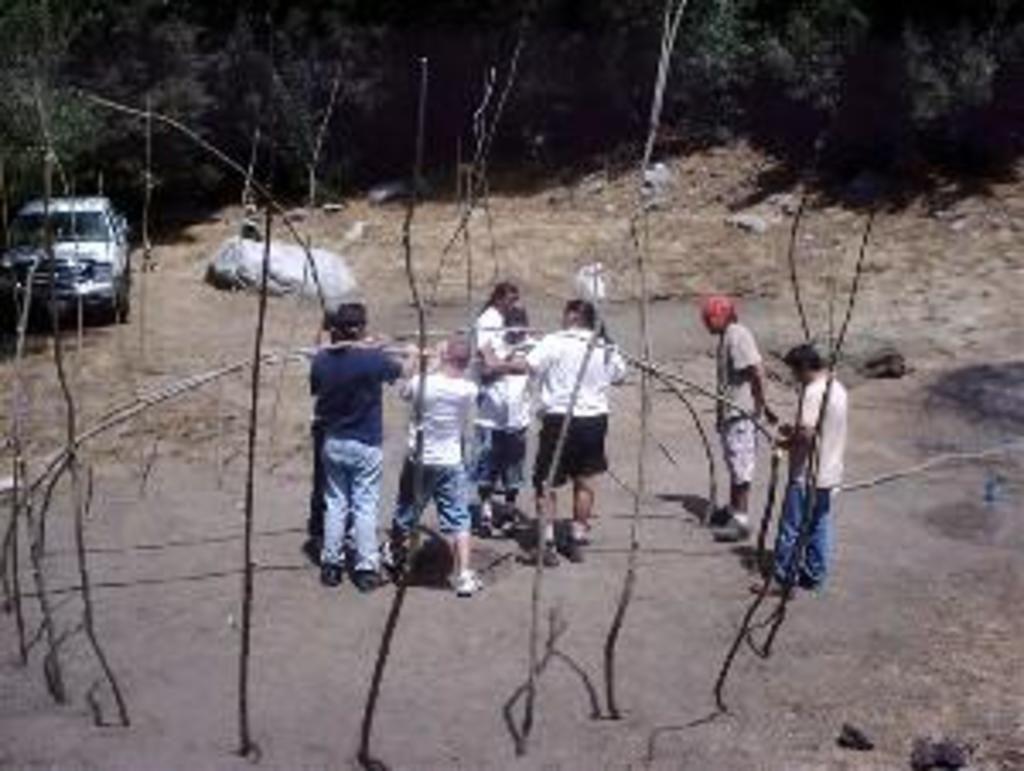What is happening in the image involving the group of people? There is a group of people standing in the image, and they appear to be holding wooden staffs. What else can be seen in the image besides the people? There is a vehicle in the image. What is visible in the background of the image? There are trees in the background of the image. How many chickens are present in the image? There are no chickens present in the image. What scientific theory is being discussed by the group of people in the image? There is no indication in the image that the group of people is discussing any scientific theory. 